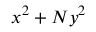<formula> <loc_0><loc_0><loc_500><loc_500>x ^ { 2 } + N y ^ { 2 }</formula> 